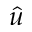<formula> <loc_0><loc_0><loc_500><loc_500>\hat { u }</formula> 